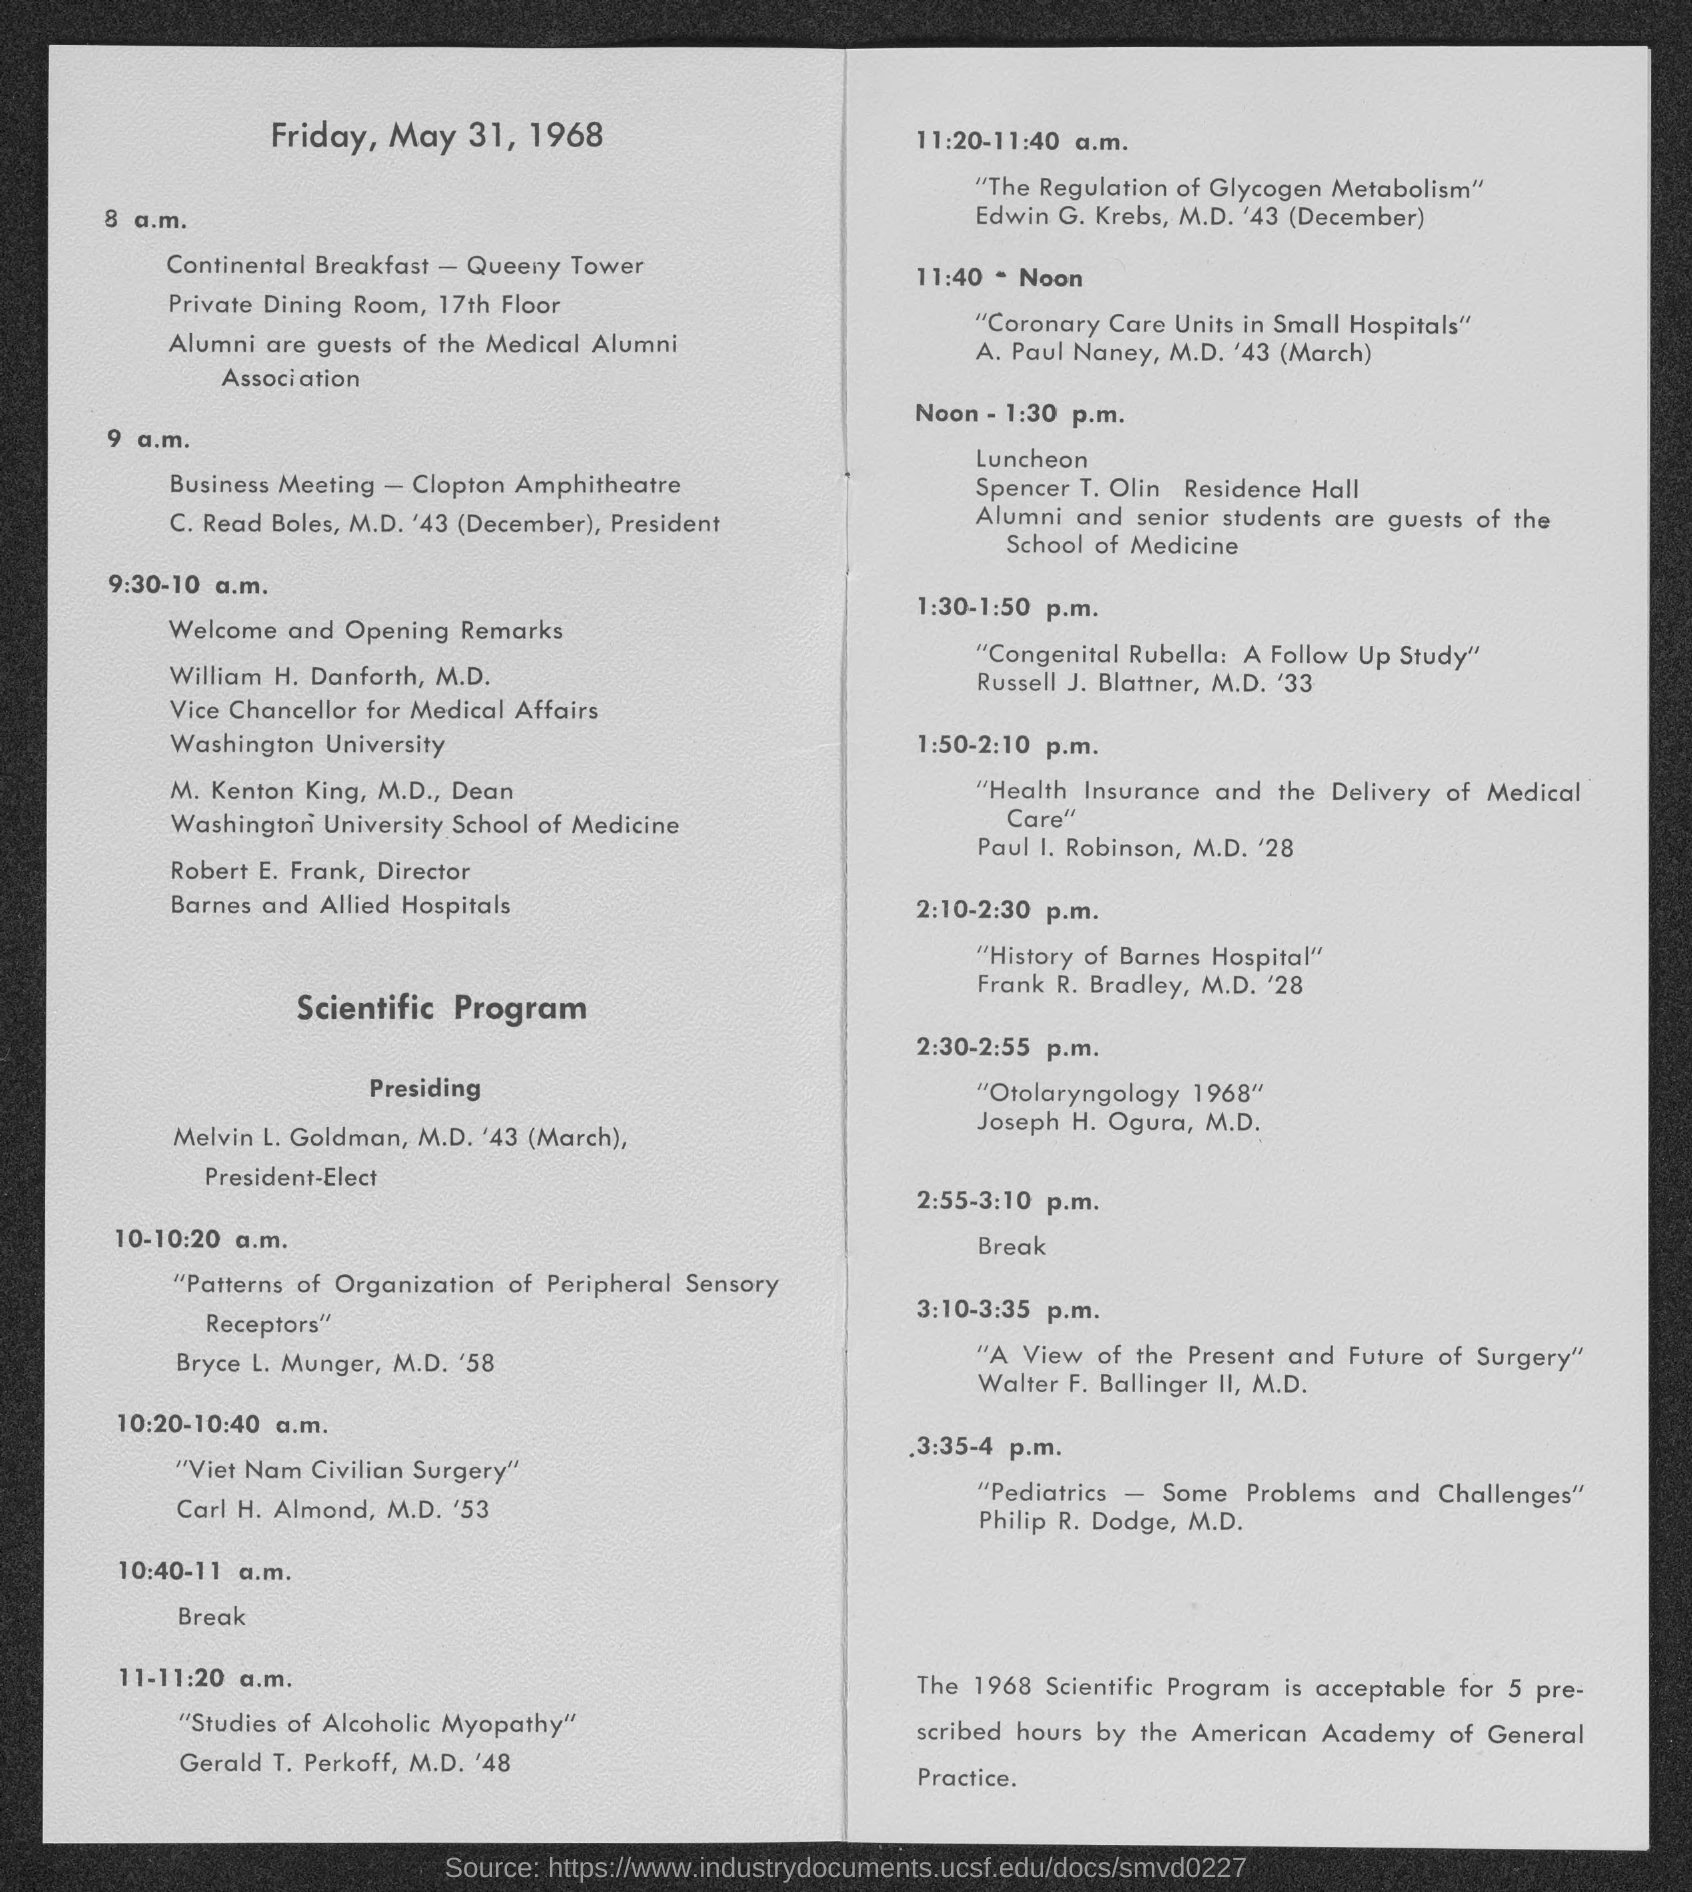Draw attention to some important aspects in this diagram. The schedule for 10:40-11 a.m. includes a break. What is the timing for the luncheon that is scheduled for noon? 1:30 p.m. has been specified as the designated time. 